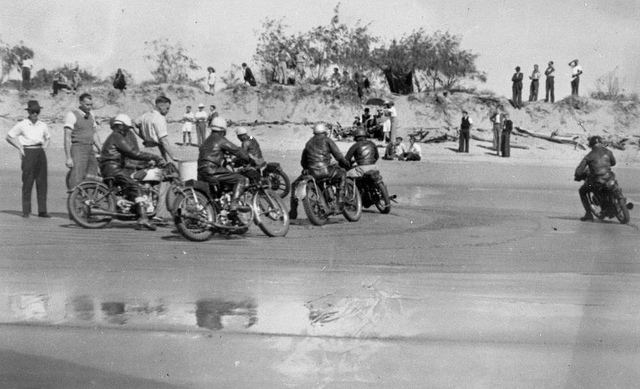Invent a wild and imaginative scenario taking place in the scene. Imagine that this beach motorcycle race is actually the first heat of an intergalactic racing championship. The racers are not just humans, but representatives of various planets, each boasting unique species with their own advanced technologies. The sandy tract is infused with alien minerals, making the surface iridescent and treacherously slippery. The spectators are a diverse crowd, ranging from humanoid figures to bizarre creatures with multiple limbs and eyes. As the race begins, the motorcycles, equipped with gravity-defying engines, start hovering inches above the ground, zooming forward with unprecedented speed. The riders navigate through checkpoints that open portals to distant galaxies, adding dimensions of space-time to the competition. At the climax, the winner is awarded a crystal trophy that holds the key to an ancient, powerful technology, sought after by civilizations from across the universe. 